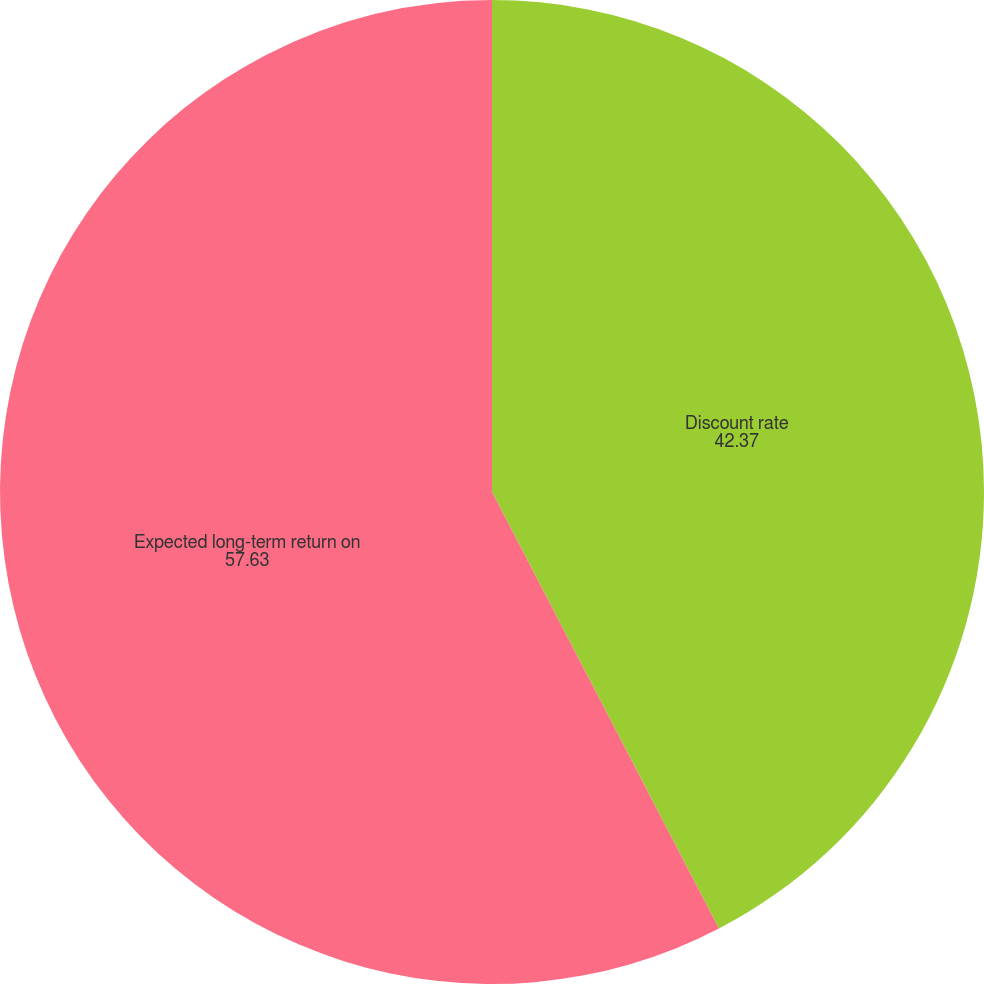Convert chart. <chart><loc_0><loc_0><loc_500><loc_500><pie_chart><fcel>Discount rate<fcel>Expected long-term return on<nl><fcel>42.37%<fcel>57.63%<nl></chart> 